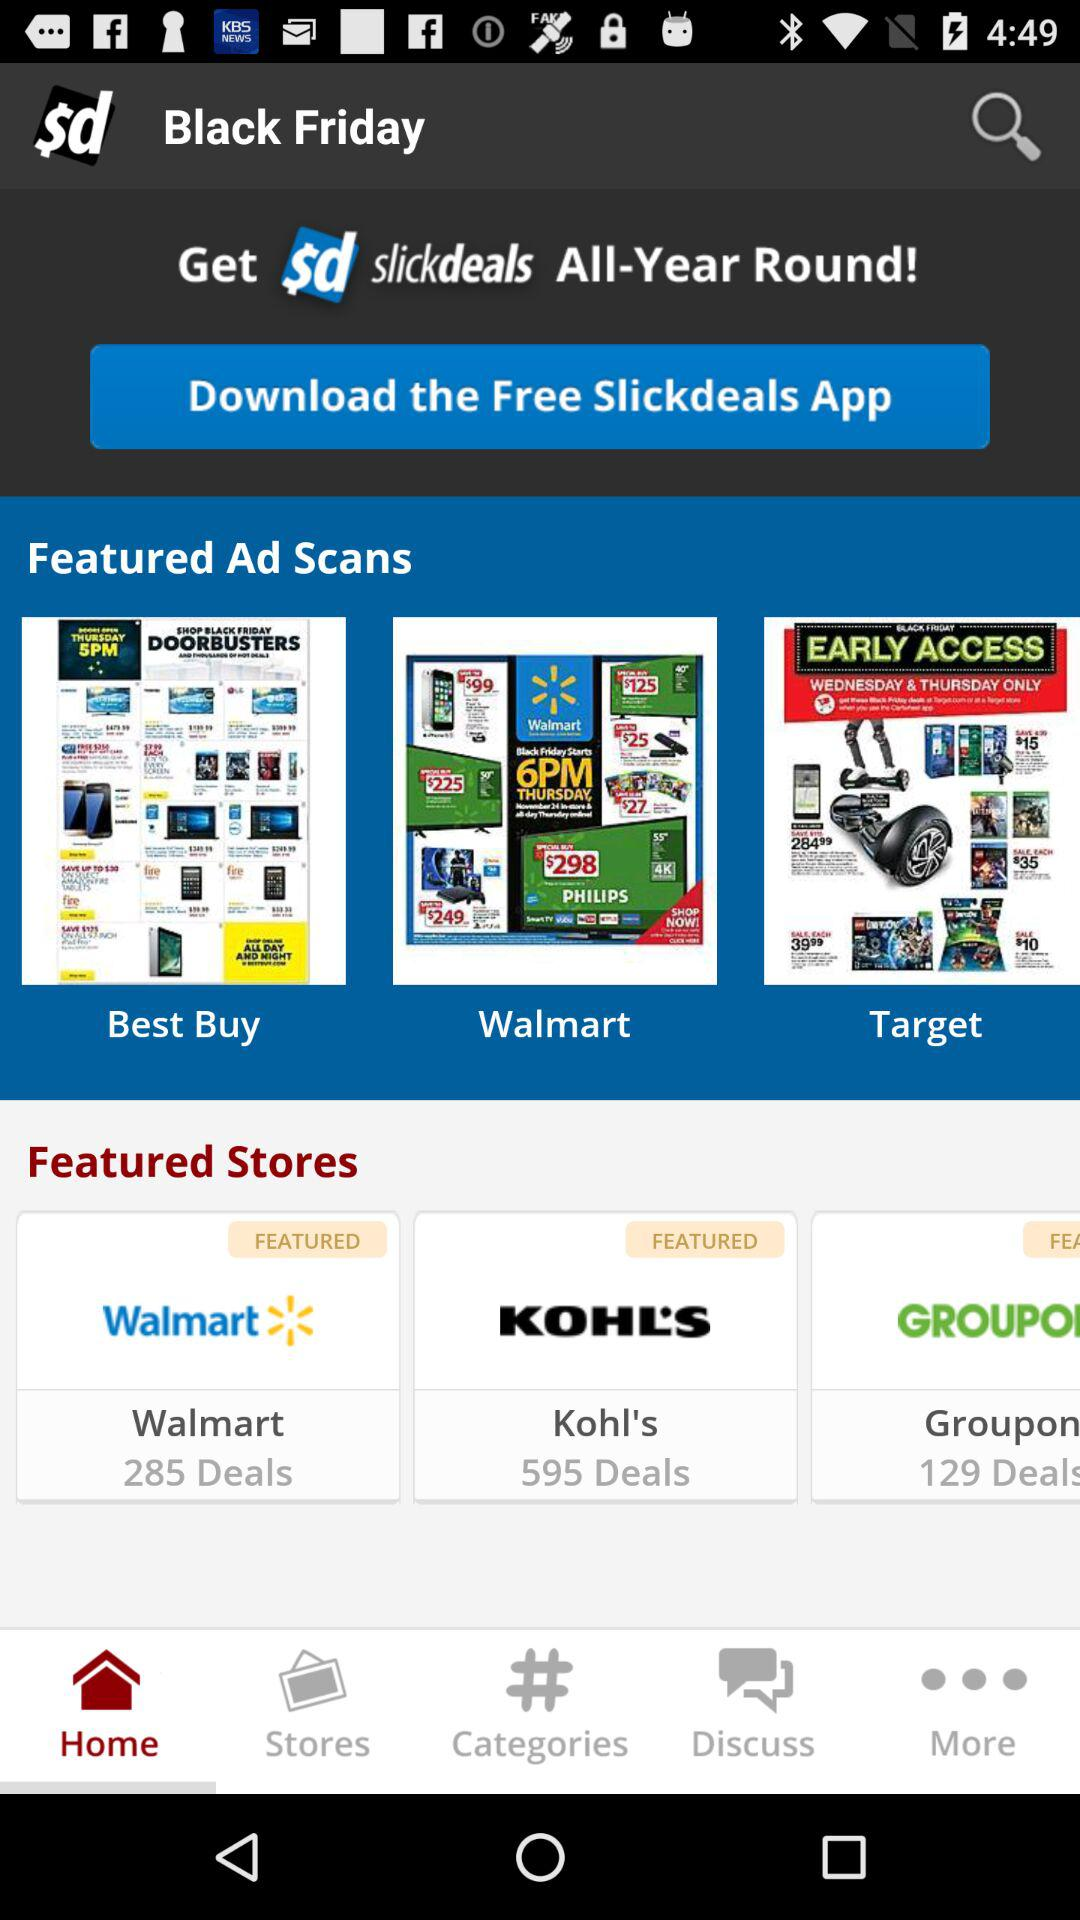How many featured stores are there?
Answer the question using a single word or phrase. 3 